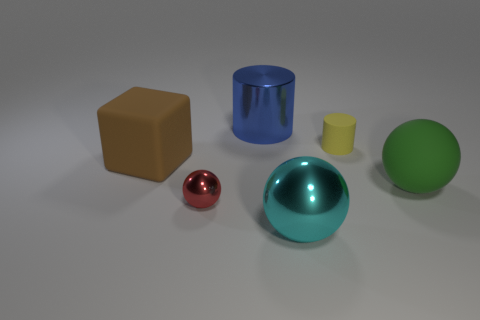Add 3 spheres. How many objects exist? 9 Subtract all cylinders. How many objects are left? 4 Add 4 spheres. How many spheres are left? 7 Add 1 big brown cubes. How many big brown cubes exist? 2 Subtract 1 yellow cylinders. How many objects are left? 5 Subtract all big red balls. Subtract all brown objects. How many objects are left? 5 